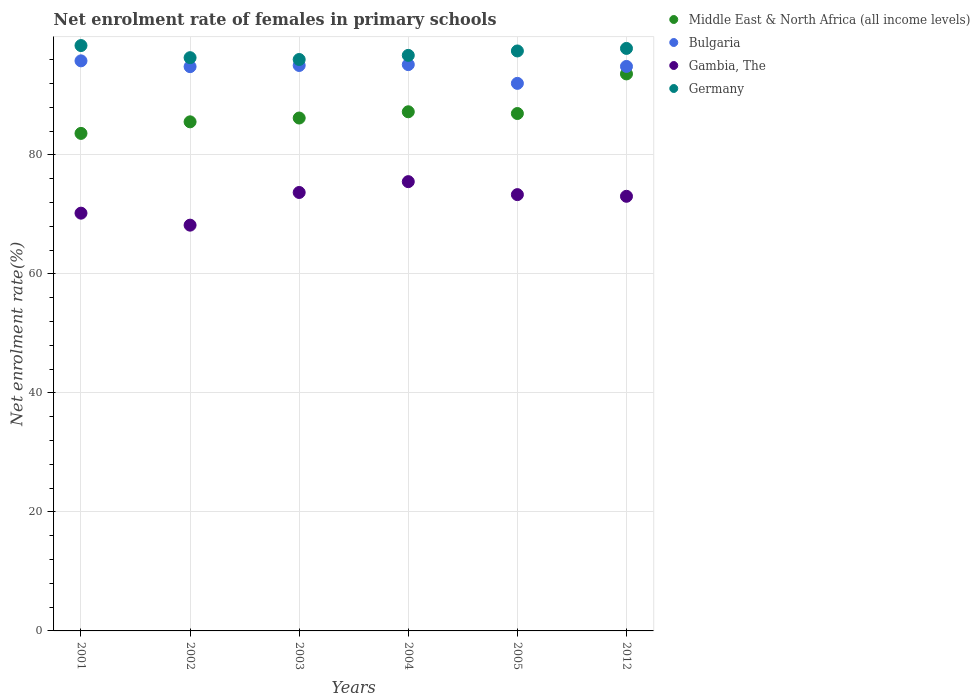Is the number of dotlines equal to the number of legend labels?
Offer a very short reply. Yes. What is the net enrolment rate of females in primary schools in Germany in 2002?
Provide a short and direct response. 96.33. Across all years, what is the maximum net enrolment rate of females in primary schools in Germany?
Make the answer very short. 98.37. Across all years, what is the minimum net enrolment rate of females in primary schools in Gambia, The?
Ensure brevity in your answer.  68.19. In which year was the net enrolment rate of females in primary schools in Middle East & North Africa (all income levels) maximum?
Keep it short and to the point. 2012. What is the total net enrolment rate of females in primary schools in Bulgaria in the graph?
Keep it short and to the point. 567.7. What is the difference between the net enrolment rate of females in primary schools in Bulgaria in 2003 and that in 2005?
Provide a short and direct response. 3.01. What is the difference between the net enrolment rate of females in primary schools in Middle East & North Africa (all income levels) in 2004 and the net enrolment rate of females in primary schools in Gambia, The in 2003?
Provide a short and direct response. 13.56. What is the average net enrolment rate of females in primary schools in Bulgaria per year?
Your answer should be very brief. 94.62. In the year 2003, what is the difference between the net enrolment rate of females in primary schools in Gambia, The and net enrolment rate of females in primary schools in Germany?
Your answer should be compact. -22.35. What is the ratio of the net enrolment rate of females in primary schools in Middle East & North Africa (all income levels) in 2002 to that in 2012?
Your answer should be very brief. 0.91. Is the net enrolment rate of females in primary schools in Gambia, The in 2002 less than that in 2003?
Your answer should be very brief. Yes. Is the difference between the net enrolment rate of females in primary schools in Gambia, The in 2001 and 2005 greater than the difference between the net enrolment rate of females in primary schools in Germany in 2001 and 2005?
Your answer should be very brief. No. What is the difference between the highest and the second highest net enrolment rate of females in primary schools in Germany?
Your answer should be very brief. 0.48. What is the difference between the highest and the lowest net enrolment rate of females in primary schools in Gambia, The?
Your answer should be compact. 7.31. In how many years, is the net enrolment rate of females in primary schools in Germany greater than the average net enrolment rate of females in primary schools in Germany taken over all years?
Your answer should be very brief. 3. Is the sum of the net enrolment rate of females in primary schools in Germany in 2001 and 2005 greater than the maximum net enrolment rate of females in primary schools in Gambia, The across all years?
Provide a short and direct response. Yes. Is it the case that in every year, the sum of the net enrolment rate of females in primary schools in Bulgaria and net enrolment rate of females in primary schools in Gambia, The  is greater than the net enrolment rate of females in primary schools in Germany?
Offer a very short reply. Yes. Is the net enrolment rate of females in primary schools in Middle East & North Africa (all income levels) strictly greater than the net enrolment rate of females in primary schools in Bulgaria over the years?
Make the answer very short. No. Are the values on the major ticks of Y-axis written in scientific E-notation?
Offer a terse response. No. Does the graph contain grids?
Give a very brief answer. Yes. How many legend labels are there?
Provide a short and direct response. 4. What is the title of the graph?
Provide a succinct answer. Net enrolment rate of females in primary schools. Does "Turks and Caicos Islands" appear as one of the legend labels in the graph?
Your answer should be compact. No. What is the label or title of the X-axis?
Make the answer very short. Years. What is the label or title of the Y-axis?
Make the answer very short. Net enrolment rate(%). What is the Net enrolment rate(%) in Middle East & North Africa (all income levels) in 2001?
Provide a succinct answer. 83.61. What is the Net enrolment rate(%) in Bulgaria in 2001?
Keep it short and to the point. 95.8. What is the Net enrolment rate(%) in Gambia, The in 2001?
Keep it short and to the point. 70.2. What is the Net enrolment rate(%) of Germany in 2001?
Keep it short and to the point. 98.37. What is the Net enrolment rate(%) in Middle East & North Africa (all income levels) in 2002?
Offer a very short reply. 85.55. What is the Net enrolment rate(%) of Bulgaria in 2002?
Make the answer very short. 94.83. What is the Net enrolment rate(%) of Gambia, The in 2002?
Your answer should be very brief. 68.19. What is the Net enrolment rate(%) in Germany in 2002?
Your response must be concise. 96.33. What is the Net enrolment rate(%) in Middle East & North Africa (all income levels) in 2003?
Your response must be concise. 86.19. What is the Net enrolment rate(%) in Bulgaria in 2003?
Keep it short and to the point. 95.02. What is the Net enrolment rate(%) in Gambia, The in 2003?
Provide a short and direct response. 73.68. What is the Net enrolment rate(%) of Germany in 2003?
Make the answer very short. 96.03. What is the Net enrolment rate(%) of Middle East & North Africa (all income levels) in 2004?
Make the answer very short. 87.24. What is the Net enrolment rate(%) of Bulgaria in 2004?
Your answer should be very brief. 95.17. What is the Net enrolment rate(%) of Gambia, The in 2004?
Your response must be concise. 75.5. What is the Net enrolment rate(%) of Germany in 2004?
Offer a very short reply. 96.72. What is the Net enrolment rate(%) of Middle East & North Africa (all income levels) in 2005?
Ensure brevity in your answer.  86.95. What is the Net enrolment rate(%) in Bulgaria in 2005?
Offer a very short reply. 92.02. What is the Net enrolment rate(%) in Gambia, The in 2005?
Your answer should be compact. 73.32. What is the Net enrolment rate(%) in Germany in 2005?
Provide a short and direct response. 97.46. What is the Net enrolment rate(%) of Middle East & North Africa (all income levels) in 2012?
Your answer should be compact. 93.61. What is the Net enrolment rate(%) in Bulgaria in 2012?
Provide a succinct answer. 94.86. What is the Net enrolment rate(%) of Gambia, The in 2012?
Your response must be concise. 73.04. What is the Net enrolment rate(%) in Germany in 2012?
Your response must be concise. 97.89. Across all years, what is the maximum Net enrolment rate(%) of Middle East & North Africa (all income levels)?
Make the answer very short. 93.61. Across all years, what is the maximum Net enrolment rate(%) of Bulgaria?
Your response must be concise. 95.8. Across all years, what is the maximum Net enrolment rate(%) of Gambia, The?
Make the answer very short. 75.5. Across all years, what is the maximum Net enrolment rate(%) of Germany?
Your response must be concise. 98.37. Across all years, what is the minimum Net enrolment rate(%) of Middle East & North Africa (all income levels)?
Offer a terse response. 83.61. Across all years, what is the minimum Net enrolment rate(%) in Bulgaria?
Provide a short and direct response. 92.02. Across all years, what is the minimum Net enrolment rate(%) of Gambia, The?
Your response must be concise. 68.19. Across all years, what is the minimum Net enrolment rate(%) in Germany?
Make the answer very short. 96.03. What is the total Net enrolment rate(%) in Middle East & North Africa (all income levels) in the graph?
Provide a succinct answer. 523.15. What is the total Net enrolment rate(%) in Bulgaria in the graph?
Your answer should be compact. 567.7. What is the total Net enrolment rate(%) of Gambia, The in the graph?
Ensure brevity in your answer.  433.94. What is the total Net enrolment rate(%) in Germany in the graph?
Keep it short and to the point. 582.81. What is the difference between the Net enrolment rate(%) of Middle East & North Africa (all income levels) in 2001 and that in 2002?
Offer a very short reply. -1.94. What is the difference between the Net enrolment rate(%) of Gambia, The in 2001 and that in 2002?
Ensure brevity in your answer.  2.02. What is the difference between the Net enrolment rate(%) of Germany in 2001 and that in 2002?
Make the answer very short. 2.04. What is the difference between the Net enrolment rate(%) of Middle East & North Africa (all income levels) in 2001 and that in 2003?
Provide a short and direct response. -2.58. What is the difference between the Net enrolment rate(%) in Bulgaria in 2001 and that in 2003?
Provide a short and direct response. 0.78. What is the difference between the Net enrolment rate(%) of Gambia, The in 2001 and that in 2003?
Provide a succinct answer. -3.48. What is the difference between the Net enrolment rate(%) of Germany in 2001 and that in 2003?
Provide a succinct answer. 2.34. What is the difference between the Net enrolment rate(%) of Middle East & North Africa (all income levels) in 2001 and that in 2004?
Make the answer very short. -3.63. What is the difference between the Net enrolment rate(%) of Bulgaria in 2001 and that in 2004?
Provide a succinct answer. 0.63. What is the difference between the Net enrolment rate(%) of Gambia, The in 2001 and that in 2004?
Your response must be concise. -5.3. What is the difference between the Net enrolment rate(%) in Germany in 2001 and that in 2004?
Make the answer very short. 1.65. What is the difference between the Net enrolment rate(%) in Middle East & North Africa (all income levels) in 2001 and that in 2005?
Your response must be concise. -3.34. What is the difference between the Net enrolment rate(%) in Bulgaria in 2001 and that in 2005?
Offer a terse response. 3.78. What is the difference between the Net enrolment rate(%) in Gambia, The in 2001 and that in 2005?
Give a very brief answer. -3.12. What is the difference between the Net enrolment rate(%) of Germany in 2001 and that in 2005?
Offer a very short reply. 0.91. What is the difference between the Net enrolment rate(%) in Middle East & North Africa (all income levels) in 2001 and that in 2012?
Ensure brevity in your answer.  -10. What is the difference between the Net enrolment rate(%) in Bulgaria in 2001 and that in 2012?
Give a very brief answer. 0.94. What is the difference between the Net enrolment rate(%) in Gambia, The in 2001 and that in 2012?
Offer a terse response. -2.83. What is the difference between the Net enrolment rate(%) in Germany in 2001 and that in 2012?
Provide a short and direct response. 0.48. What is the difference between the Net enrolment rate(%) in Middle East & North Africa (all income levels) in 2002 and that in 2003?
Offer a very short reply. -0.64. What is the difference between the Net enrolment rate(%) of Bulgaria in 2002 and that in 2003?
Offer a very short reply. -0.2. What is the difference between the Net enrolment rate(%) of Gambia, The in 2002 and that in 2003?
Your answer should be compact. -5.49. What is the difference between the Net enrolment rate(%) of Germany in 2002 and that in 2003?
Keep it short and to the point. 0.31. What is the difference between the Net enrolment rate(%) in Middle East & North Africa (all income levels) in 2002 and that in 2004?
Give a very brief answer. -1.69. What is the difference between the Net enrolment rate(%) in Bulgaria in 2002 and that in 2004?
Provide a short and direct response. -0.34. What is the difference between the Net enrolment rate(%) of Gambia, The in 2002 and that in 2004?
Your answer should be very brief. -7.31. What is the difference between the Net enrolment rate(%) in Germany in 2002 and that in 2004?
Offer a terse response. -0.39. What is the difference between the Net enrolment rate(%) of Middle East & North Africa (all income levels) in 2002 and that in 2005?
Your response must be concise. -1.4. What is the difference between the Net enrolment rate(%) in Bulgaria in 2002 and that in 2005?
Provide a succinct answer. 2.81. What is the difference between the Net enrolment rate(%) in Gambia, The in 2002 and that in 2005?
Your answer should be compact. -5.13. What is the difference between the Net enrolment rate(%) of Germany in 2002 and that in 2005?
Your response must be concise. -1.13. What is the difference between the Net enrolment rate(%) in Middle East & North Africa (all income levels) in 2002 and that in 2012?
Your answer should be compact. -8.05. What is the difference between the Net enrolment rate(%) in Bulgaria in 2002 and that in 2012?
Offer a terse response. -0.04. What is the difference between the Net enrolment rate(%) in Gambia, The in 2002 and that in 2012?
Give a very brief answer. -4.85. What is the difference between the Net enrolment rate(%) of Germany in 2002 and that in 2012?
Offer a terse response. -1.56. What is the difference between the Net enrolment rate(%) of Middle East & North Africa (all income levels) in 2003 and that in 2004?
Your answer should be compact. -1.05. What is the difference between the Net enrolment rate(%) in Bulgaria in 2003 and that in 2004?
Offer a terse response. -0.14. What is the difference between the Net enrolment rate(%) in Gambia, The in 2003 and that in 2004?
Your response must be concise. -1.82. What is the difference between the Net enrolment rate(%) in Germany in 2003 and that in 2004?
Make the answer very short. -0.69. What is the difference between the Net enrolment rate(%) in Middle East & North Africa (all income levels) in 2003 and that in 2005?
Provide a short and direct response. -0.76. What is the difference between the Net enrolment rate(%) of Bulgaria in 2003 and that in 2005?
Provide a succinct answer. 3.01. What is the difference between the Net enrolment rate(%) of Gambia, The in 2003 and that in 2005?
Offer a very short reply. 0.36. What is the difference between the Net enrolment rate(%) of Germany in 2003 and that in 2005?
Your answer should be very brief. -1.43. What is the difference between the Net enrolment rate(%) in Middle East & North Africa (all income levels) in 2003 and that in 2012?
Provide a short and direct response. -7.41. What is the difference between the Net enrolment rate(%) in Bulgaria in 2003 and that in 2012?
Ensure brevity in your answer.  0.16. What is the difference between the Net enrolment rate(%) in Gambia, The in 2003 and that in 2012?
Ensure brevity in your answer.  0.64. What is the difference between the Net enrolment rate(%) of Germany in 2003 and that in 2012?
Your answer should be very brief. -1.86. What is the difference between the Net enrolment rate(%) in Middle East & North Africa (all income levels) in 2004 and that in 2005?
Give a very brief answer. 0.29. What is the difference between the Net enrolment rate(%) in Bulgaria in 2004 and that in 2005?
Offer a terse response. 3.15. What is the difference between the Net enrolment rate(%) of Gambia, The in 2004 and that in 2005?
Offer a very short reply. 2.18. What is the difference between the Net enrolment rate(%) of Germany in 2004 and that in 2005?
Offer a very short reply. -0.74. What is the difference between the Net enrolment rate(%) of Middle East & North Africa (all income levels) in 2004 and that in 2012?
Give a very brief answer. -6.36. What is the difference between the Net enrolment rate(%) in Bulgaria in 2004 and that in 2012?
Give a very brief answer. 0.31. What is the difference between the Net enrolment rate(%) in Gambia, The in 2004 and that in 2012?
Your answer should be very brief. 2.46. What is the difference between the Net enrolment rate(%) in Germany in 2004 and that in 2012?
Provide a short and direct response. -1.17. What is the difference between the Net enrolment rate(%) of Middle East & North Africa (all income levels) in 2005 and that in 2012?
Ensure brevity in your answer.  -6.65. What is the difference between the Net enrolment rate(%) of Bulgaria in 2005 and that in 2012?
Ensure brevity in your answer.  -2.85. What is the difference between the Net enrolment rate(%) in Gambia, The in 2005 and that in 2012?
Make the answer very short. 0.28. What is the difference between the Net enrolment rate(%) of Germany in 2005 and that in 2012?
Keep it short and to the point. -0.43. What is the difference between the Net enrolment rate(%) of Middle East & North Africa (all income levels) in 2001 and the Net enrolment rate(%) of Bulgaria in 2002?
Give a very brief answer. -11.22. What is the difference between the Net enrolment rate(%) in Middle East & North Africa (all income levels) in 2001 and the Net enrolment rate(%) in Gambia, The in 2002?
Your answer should be compact. 15.42. What is the difference between the Net enrolment rate(%) of Middle East & North Africa (all income levels) in 2001 and the Net enrolment rate(%) of Germany in 2002?
Your answer should be very brief. -12.72. What is the difference between the Net enrolment rate(%) in Bulgaria in 2001 and the Net enrolment rate(%) in Gambia, The in 2002?
Ensure brevity in your answer.  27.61. What is the difference between the Net enrolment rate(%) of Bulgaria in 2001 and the Net enrolment rate(%) of Germany in 2002?
Your answer should be very brief. -0.53. What is the difference between the Net enrolment rate(%) in Gambia, The in 2001 and the Net enrolment rate(%) in Germany in 2002?
Your response must be concise. -26.13. What is the difference between the Net enrolment rate(%) of Middle East & North Africa (all income levels) in 2001 and the Net enrolment rate(%) of Bulgaria in 2003?
Offer a terse response. -11.41. What is the difference between the Net enrolment rate(%) of Middle East & North Africa (all income levels) in 2001 and the Net enrolment rate(%) of Gambia, The in 2003?
Keep it short and to the point. 9.93. What is the difference between the Net enrolment rate(%) of Middle East & North Africa (all income levels) in 2001 and the Net enrolment rate(%) of Germany in 2003?
Your answer should be compact. -12.42. What is the difference between the Net enrolment rate(%) in Bulgaria in 2001 and the Net enrolment rate(%) in Gambia, The in 2003?
Your answer should be compact. 22.12. What is the difference between the Net enrolment rate(%) in Bulgaria in 2001 and the Net enrolment rate(%) in Germany in 2003?
Offer a terse response. -0.23. What is the difference between the Net enrolment rate(%) in Gambia, The in 2001 and the Net enrolment rate(%) in Germany in 2003?
Provide a succinct answer. -25.82. What is the difference between the Net enrolment rate(%) of Middle East & North Africa (all income levels) in 2001 and the Net enrolment rate(%) of Bulgaria in 2004?
Offer a terse response. -11.56. What is the difference between the Net enrolment rate(%) of Middle East & North Africa (all income levels) in 2001 and the Net enrolment rate(%) of Gambia, The in 2004?
Your answer should be compact. 8.11. What is the difference between the Net enrolment rate(%) in Middle East & North Africa (all income levels) in 2001 and the Net enrolment rate(%) in Germany in 2004?
Offer a terse response. -13.11. What is the difference between the Net enrolment rate(%) in Bulgaria in 2001 and the Net enrolment rate(%) in Gambia, The in 2004?
Give a very brief answer. 20.3. What is the difference between the Net enrolment rate(%) in Bulgaria in 2001 and the Net enrolment rate(%) in Germany in 2004?
Offer a terse response. -0.92. What is the difference between the Net enrolment rate(%) in Gambia, The in 2001 and the Net enrolment rate(%) in Germany in 2004?
Your answer should be very brief. -26.52. What is the difference between the Net enrolment rate(%) of Middle East & North Africa (all income levels) in 2001 and the Net enrolment rate(%) of Bulgaria in 2005?
Your response must be concise. -8.41. What is the difference between the Net enrolment rate(%) of Middle East & North Africa (all income levels) in 2001 and the Net enrolment rate(%) of Gambia, The in 2005?
Your response must be concise. 10.29. What is the difference between the Net enrolment rate(%) of Middle East & North Africa (all income levels) in 2001 and the Net enrolment rate(%) of Germany in 2005?
Ensure brevity in your answer.  -13.85. What is the difference between the Net enrolment rate(%) in Bulgaria in 2001 and the Net enrolment rate(%) in Gambia, The in 2005?
Your response must be concise. 22.48. What is the difference between the Net enrolment rate(%) in Bulgaria in 2001 and the Net enrolment rate(%) in Germany in 2005?
Your answer should be compact. -1.66. What is the difference between the Net enrolment rate(%) of Gambia, The in 2001 and the Net enrolment rate(%) of Germany in 2005?
Offer a terse response. -27.26. What is the difference between the Net enrolment rate(%) in Middle East & North Africa (all income levels) in 2001 and the Net enrolment rate(%) in Bulgaria in 2012?
Offer a very short reply. -11.25. What is the difference between the Net enrolment rate(%) of Middle East & North Africa (all income levels) in 2001 and the Net enrolment rate(%) of Gambia, The in 2012?
Your response must be concise. 10.57. What is the difference between the Net enrolment rate(%) in Middle East & North Africa (all income levels) in 2001 and the Net enrolment rate(%) in Germany in 2012?
Ensure brevity in your answer.  -14.28. What is the difference between the Net enrolment rate(%) in Bulgaria in 2001 and the Net enrolment rate(%) in Gambia, The in 2012?
Make the answer very short. 22.76. What is the difference between the Net enrolment rate(%) of Bulgaria in 2001 and the Net enrolment rate(%) of Germany in 2012?
Provide a succinct answer. -2.09. What is the difference between the Net enrolment rate(%) in Gambia, The in 2001 and the Net enrolment rate(%) in Germany in 2012?
Your response must be concise. -27.69. What is the difference between the Net enrolment rate(%) of Middle East & North Africa (all income levels) in 2002 and the Net enrolment rate(%) of Bulgaria in 2003?
Offer a very short reply. -9.47. What is the difference between the Net enrolment rate(%) in Middle East & North Africa (all income levels) in 2002 and the Net enrolment rate(%) in Gambia, The in 2003?
Your response must be concise. 11.87. What is the difference between the Net enrolment rate(%) of Middle East & North Africa (all income levels) in 2002 and the Net enrolment rate(%) of Germany in 2003?
Ensure brevity in your answer.  -10.48. What is the difference between the Net enrolment rate(%) in Bulgaria in 2002 and the Net enrolment rate(%) in Gambia, The in 2003?
Offer a terse response. 21.15. What is the difference between the Net enrolment rate(%) in Bulgaria in 2002 and the Net enrolment rate(%) in Germany in 2003?
Provide a succinct answer. -1.2. What is the difference between the Net enrolment rate(%) of Gambia, The in 2002 and the Net enrolment rate(%) of Germany in 2003?
Provide a succinct answer. -27.84. What is the difference between the Net enrolment rate(%) of Middle East & North Africa (all income levels) in 2002 and the Net enrolment rate(%) of Bulgaria in 2004?
Keep it short and to the point. -9.62. What is the difference between the Net enrolment rate(%) of Middle East & North Africa (all income levels) in 2002 and the Net enrolment rate(%) of Gambia, The in 2004?
Your response must be concise. 10.05. What is the difference between the Net enrolment rate(%) of Middle East & North Africa (all income levels) in 2002 and the Net enrolment rate(%) of Germany in 2004?
Offer a terse response. -11.17. What is the difference between the Net enrolment rate(%) of Bulgaria in 2002 and the Net enrolment rate(%) of Gambia, The in 2004?
Offer a terse response. 19.32. What is the difference between the Net enrolment rate(%) in Bulgaria in 2002 and the Net enrolment rate(%) in Germany in 2004?
Keep it short and to the point. -1.9. What is the difference between the Net enrolment rate(%) of Gambia, The in 2002 and the Net enrolment rate(%) of Germany in 2004?
Ensure brevity in your answer.  -28.53. What is the difference between the Net enrolment rate(%) of Middle East & North Africa (all income levels) in 2002 and the Net enrolment rate(%) of Bulgaria in 2005?
Provide a succinct answer. -6.46. What is the difference between the Net enrolment rate(%) of Middle East & North Africa (all income levels) in 2002 and the Net enrolment rate(%) of Gambia, The in 2005?
Your answer should be very brief. 12.23. What is the difference between the Net enrolment rate(%) of Middle East & North Africa (all income levels) in 2002 and the Net enrolment rate(%) of Germany in 2005?
Make the answer very short. -11.91. What is the difference between the Net enrolment rate(%) in Bulgaria in 2002 and the Net enrolment rate(%) in Gambia, The in 2005?
Provide a succinct answer. 21.51. What is the difference between the Net enrolment rate(%) in Bulgaria in 2002 and the Net enrolment rate(%) in Germany in 2005?
Keep it short and to the point. -2.64. What is the difference between the Net enrolment rate(%) of Gambia, The in 2002 and the Net enrolment rate(%) of Germany in 2005?
Offer a very short reply. -29.27. What is the difference between the Net enrolment rate(%) of Middle East & North Africa (all income levels) in 2002 and the Net enrolment rate(%) of Bulgaria in 2012?
Offer a terse response. -9.31. What is the difference between the Net enrolment rate(%) in Middle East & North Africa (all income levels) in 2002 and the Net enrolment rate(%) in Gambia, The in 2012?
Make the answer very short. 12.51. What is the difference between the Net enrolment rate(%) in Middle East & North Africa (all income levels) in 2002 and the Net enrolment rate(%) in Germany in 2012?
Keep it short and to the point. -12.34. What is the difference between the Net enrolment rate(%) in Bulgaria in 2002 and the Net enrolment rate(%) in Gambia, The in 2012?
Your answer should be compact. 21.79. What is the difference between the Net enrolment rate(%) in Bulgaria in 2002 and the Net enrolment rate(%) in Germany in 2012?
Keep it short and to the point. -3.06. What is the difference between the Net enrolment rate(%) of Gambia, The in 2002 and the Net enrolment rate(%) of Germany in 2012?
Give a very brief answer. -29.7. What is the difference between the Net enrolment rate(%) of Middle East & North Africa (all income levels) in 2003 and the Net enrolment rate(%) of Bulgaria in 2004?
Offer a very short reply. -8.98. What is the difference between the Net enrolment rate(%) in Middle East & North Africa (all income levels) in 2003 and the Net enrolment rate(%) in Gambia, The in 2004?
Provide a short and direct response. 10.69. What is the difference between the Net enrolment rate(%) in Middle East & North Africa (all income levels) in 2003 and the Net enrolment rate(%) in Germany in 2004?
Keep it short and to the point. -10.53. What is the difference between the Net enrolment rate(%) of Bulgaria in 2003 and the Net enrolment rate(%) of Gambia, The in 2004?
Your answer should be very brief. 19.52. What is the difference between the Net enrolment rate(%) of Bulgaria in 2003 and the Net enrolment rate(%) of Germany in 2004?
Give a very brief answer. -1.7. What is the difference between the Net enrolment rate(%) of Gambia, The in 2003 and the Net enrolment rate(%) of Germany in 2004?
Your response must be concise. -23.04. What is the difference between the Net enrolment rate(%) in Middle East & North Africa (all income levels) in 2003 and the Net enrolment rate(%) in Bulgaria in 2005?
Offer a terse response. -5.82. What is the difference between the Net enrolment rate(%) in Middle East & North Africa (all income levels) in 2003 and the Net enrolment rate(%) in Gambia, The in 2005?
Ensure brevity in your answer.  12.87. What is the difference between the Net enrolment rate(%) in Middle East & North Africa (all income levels) in 2003 and the Net enrolment rate(%) in Germany in 2005?
Provide a short and direct response. -11.27. What is the difference between the Net enrolment rate(%) in Bulgaria in 2003 and the Net enrolment rate(%) in Gambia, The in 2005?
Offer a very short reply. 21.7. What is the difference between the Net enrolment rate(%) in Bulgaria in 2003 and the Net enrolment rate(%) in Germany in 2005?
Offer a very short reply. -2.44. What is the difference between the Net enrolment rate(%) of Gambia, The in 2003 and the Net enrolment rate(%) of Germany in 2005?
Your answer should be very brief. -23.78. What is the difference between the Net enrolment rate(%) of Middle East & North Africa (all income levels) in 2003 and the Net enrolment rate(%) of Bulgaria in 2012?
Provide a succinct answer. -8.67. What is the difference between the Net enrolment rate(%) in Middle East & North Africa (all income levels) in 2003 and the Net enrolment rate(%) in Gambia, The in 2012?
Provide a short and direct response. 13.15. What is the difference between the Net enrolment rate(%) of Middle East & North Africa (all income levels) in 2003 and the Net enrolment rate(%) of Germany in 2012?
Provide a succinct answer. -11.7. What is the difference between the Net enrolment rate(%) of Bulgaria in 2003 and the Net enrolment rate(%) of Gambia, The in 2012?
Your answer should be compact. 21.98. What is the difference between the Net enrolment rate(%) in Bulgaria in 2003 and the Net enrolment rate(%) in Germany in 2012?
Your response must be concise. -2.87. What is the difference between the Net enrolment rate(%) in Gambia, The in 2003 and the Net enrolment rate(%) in Germany in 2012?
Make the answer very short. -24.21. What is the difference between the Net enrolment rate(%) in Middle East & North Africa (all income levels) in 2004 and the Net enrolment rate(%) in Bulgaria in 2005?
Ensure brevity in your answer.  -4.77. What is the difference between the Net enrolment rate(%) of Middle East & North Africa (all income levels) in 2004 and the Net enrolment rate(%) of Gambia, The in 2005?
Keep it short and to the point. 13.92. What is the difference between the Net enrolment rate(%) in Middle East & North Africa (all income levels) in 2004 and the Net enrolment rate(%) in Germany in 2005?
Your response must be concise. -10.22. What is the difference between the Net enrolment rate(%) in Bulgaria in 2004 and the Net enrolment rate(%) in Gambia, The in 2005?
Give a very brief answer. 21.85. What is the difference between the Net enrolment rate(%) of Bulgaria in 2004 and the Net enrolment rate(%) of Germany in 2005?
Provide a short and direct response. -2.29. What is the difference between the Net enrolment rate(%) of Gambia, The in 2004 and the Net enrolment rate(%) of Germany in 2005?
Give a very brief answer. -21.96. What is the difference between the Net enrolment rate(%) in Middle East & North Africa (all income levels) in 2004 and the Net enrolment rate(%) in Bulgaria in 2012?
Provide a short and direct response. -7.62. What is the difference between the Net enrolment rate(%) of Middle East & North Africa (all income levels) in 2004 and the Net enrolment rate(%) of Gambia, The in 2012?
Your answer should be compact. 14.2. What is the difference between the Net enrolment rate(%) of Middle East & North Africa (all income levels) in 2004 and the Net enrolment rate(%) of Germany in 2012?
Provide a succinct answer. -10.65. What is the difference between the Net enrolment rate(%) in Bulgaria in 2004 and the Net enrolment rate(%) in Gambia, The in 2012?
Ensure brevity in your answer.  22.13. What is the difference between the Net enrolment rate(%) in Bulgaria in 2004 and the Net enrolment rate(%) in Germany in 2012?
Provide a short and direct response. -2.72. What is the difference between the Net enrolment rate(%) in Gambia, The in 2004 and the Net enrolment rate(%) in Germany in 2012?
Provide a succinct answer. -22.39. What is the difference between the Net enrolment rate(%) in Middle East & North Africa (all income levels) in 2005 and the Net enrolment rate(%) in Bulgaria in 2012?
Give a very brief answer. -7.91. What is the difference between the Net enrolment rate(%) in Middle East & North Africa (all income levels) in 2005 and the Net enrolment rate(%) in Gambia, The in 2012?
Give a very brief answer. 13.91. What is the difference between the Net enrolment rate(%) in Middle East & North Africa (all income levels) in 2005 and the Net enrolment rate(%) in Germany in 2012?
Your response must be concise. -10.94. What is the difference between the Net enrolment rate(%) of Bulgaria in 2005 and the Net enrolment rate(%) of Gambia, The in 2012?
Provide a succinct answer. 18.98. What is the difference between the Net enrolment rate(%) of Bulgaria in 2005 and the Net enrolment rate(%) of Germany in 2012?
Offer a terse response. -5.87. What is the difference between the Net enrolment rate(%) of Gambia, The in 2005 and the Net enrolment rate(%) of Germany in 2012?
Your answer should be very brief. -24.57. What is the average Net enrolment rate(%) in Middle East & North Africa (all income levels) per year?
Your answer should be very brief. 87.19. What is the average Net enrolment rate(%) in Bulgaria per year?
Make the answer very short. 94.62. What is the average Net enrolment rate(%) of Gambia, The per year?
Make the answer very short. 72.32. What is the average Net enrolment rate(%) of Germany per year?
Provide a short and direct response. 97.14. In the year 2001, what is the difference between the Net enrolment rate(%) of Middle East & North Africa (all income levels) and Net enrolment rate(%) of Bulgaria?
Your answer should be compact. -12.19. In the year 2001, what is the difference between the Net enrolment rate(%) of Middle East & North Africa (all income levels) and Net enrolment rate(%) of Gambia, The?
Give a very brief answer. 13.4. In the year 2001, what is the difference between the Net enrolment rate(%) in Middle East & North Africa (all income levels) and Net enrolment rate(%) in Germany?
Ensure brevity in your answer.  -14.76. In the year 2001, what is the difference between the Net enrolment rate(%) of Bulgaria and Net enrolment rate(%) of Gambia, The?
Make the answer very short. 25.6. In the year 2001, what is the difference between the Net enrolment rate(%) of Bulgaria and Net enrolment rate(%) of Germany?
Your answer should be compact. -2.57. In the year 2001, what is the difference between the Net enrolment rate(%) in Gambia, The and Net enrolment rate(%) in Germany?
Your answer should be very brief. -28.17. In the year 2002, what is the difference between the Net enrolment rate(%) in Middle East & North Africa (all income levels) and Net enrolment rate(%) in Bulgaria?
Provide a short and direct response. -9.27. In the year 2002, what is the difference between the Net enrolment rate(%) of Middle East & North Africa (all income levels) and Net enrolment rate(%) of Gambia, The?
Offer a terse response. 17.36. In the year 2002, what is the difference between the Net enrolment rate(%) in Middle East & North Africa (all income levels) and Net enrolment rate(%) in Germany?
Keep it short and to the point. -10.78. In the year 2002, what is the difference between the Net enrolment rate(%) of Bulgaria and Net enrolment rate(%) of Gambia, The?
Offer a very short reply. 26.64. In the year 2002, what is the difference between the Net enrolment rate(%) of Bulgaria and Net enrolment rate(%) of Germany?
Provide a succinct answer. -1.51. In the year 2002, what is the difference between the Net enrolment rate(%) of Gambia, The and Net enrolment rate(%) of Germany?
Ensure brevity in your answer.  -28.15. In the year 2003, what is the difference between the Net enrolment rate(%) of Middle East & North Africa (all income levels) and Net enrolment rate(%) of Bulgaria?
Your response must be concise. -8.83. In the year 2003, what is the difference between the Net enrolment rate(%) of Middle East & North Africa (all income levels) and Net enrolment rate(%) of Gambia, The?
Ensure brevity in your answer.  12.51. In the year 2003, what is the difference between the Net enrolment rate(%) in Middle East & North Africa (all income levels) and Net enrolment rate(%) in Germany?
Ensure brevity in your answer.  -9.84. In the year 2003, what is the difference between the Net enrolment rate(%) of Bulgaria and Net enrolment rate(%) of Gambia, The?
Provide a succinct answer. 21.34. In the year 2003, what is the difference between the Net enrolment rate(%) of Bulgaria and Net enrolment rate(%) of Germany?
Your response must be concise. -1. In the year 2003, what is the difference between the Net enrolment rate(%) in Gambia, The and Net enrolment rate(%) in Germany?
Offer a very short reply. -22.35. In the year 2004, what is the difference between the Net enrolment rate(%) in Middle East & North Africa (all income levels) and Net enrolment rate(%) in Bulgaria?
Ensure brevity in your answer.  -7.93. In the year 2004, what is the difference between the Net enrolment rate(%) in Middle East & North Africa (all income levels) and Net enrolment rate(%) in Gambia, The?
Provide a succinct answer. 11.74. In the year 2004, what is the difference between the Net enrolment rate(%) in Middle East & North Africa (all income levels) and Net enrolment rate(%) in Germany?
Provide a succinct answer. -9.48. In the year 2004, what is the difference between the Net enrolment rate(%) of Bulgaria and Net enrolment rate(%) of Gambia, The?
Keep it short and to the point. 19.67. In the year 2004, what is the difference between the Net enrolment rate(%) in Bulgaria and Net enrolment rate(%) in Germany?
Offer a terse response. -1.55. In the year 2004, what is the difference between the Net enrolment rate(%) in Gambia, The and Net enrolment rate(%) in Germany?
Offer a terse response. -21.22. In the year 2005, what is the difference between the Net enrolment rate(%) of Middle East & North Africa (all income levels) and Net enrolment rate(%) of Bulgaria?
Your answer should be compact. -5.07. In the year 2005, what is the difference between the Net enrolment rate(%) of Middle East & North Africa (all income levels) and Net enrolment rate(%) of Gambia, The?
Offer a very short reply. 13.63. In the year 2005, what is the difference between the Net enrolment rate(%) in Middle East & North Africa (all income levels) and Net enrolment rate(%) in Germany?
Provide a short and direct response. -10.51. In the year 2005, what is the difference between the Net enrolment rate(%) of Bulgaria and Net enrolment rate(%) of Gambia, The?
Give a very brief answer. 18.7. In the year 2005, what is the difference between the Net enrolment rate(%) of Bulgaria and Net enrolment rate(%) of Germany?
Keep it short and to the point. -5.45. In the year 2005, what is the difference between the Net enrolment rate(%) in Gambia, The and Net enrolment rate(%) in Germany?
Keep it short and to the point. -24.14. In the year 2012, what is the difference between the Net enrolment rate(%) in Middle East & North Africa (all income levels) and Net enrolment rate(%) in Bulgaria?
Keep it short and to the point. -1.26. In the year 2012, what is the difference between the Net enrolment rate(%) in Middle East & North Africa (all income levels) and Net enrolment rate(%) in Gambia, The?
Provide a short and direct response. 20.57. In the year 2012, what is the difference between the Net enrolment rate(%) in Middle East & North Africa (all income levels) and Net enrolment rate(%) in Germany?
Your answer should be compact. -4.29. In the year 2012, what is the difference between the Net enrolment rate(%) in Bulgaria and Net enrolment rate(%) in Gambia, The?
Keep it short and to the point. 21.82. In the year 2012, what is the difference between the Net enrolment rate(%) of Bulgaria and Net enrolment rate(%) of Germany?
Make the answer very short. -3.03. In the year 2012, what is the difference between the Net enrolment rate(%) in Gambia, The and Net enrolment rate(%) in Germany?
Provide a short and direct response. -24.85. What is the ratio of the Net enrolment rate(%) of Middle East & North Africa (all income levels) in 2001 to that in 2002?
Provide a succinct answer. 0.98. What is the ratio of the Net enrolment rate(%) in Bulgaria in 2001 to that in 2002?
Make the answer very short. 1.01. What is the ratio of the Net enrolment rate(%) of Gambia, The in 2001 to that in 2002?
Provide a succinct answer. 1.03. What is the ratio of the Net enrolment rate(%) in Germany in 2001 to that in 2002?
Your answer should be compact. 1.02. What is the ratio of the Net enrolment rate(%) of Middle East & North Africa (all income levels) in 2001 to that in 2003?
Give a very brief answer. 0.97. What is the ratio of the Net enrolment rate(%) in Bulgaria in 2001 to that in 2003?
Provide a succinct answer. 1.01. What is the ratio of the Net enrolment rate(%) in Gambia, The in 2001 to that in 2003?
Your answer should be compact. 0.95. What is the ratio of the Net enrolment rate(%) in Germany in 2001 to that in 2003?
Your answer should be compact. 1.02. What is the ratio of the Net enrolment rate(%) in Middle East & North Africa (all income levels) in 2001 to that in 2004?
Provide a short and direct response. 0.96. What is the ratio of the Net enrolment rate(%) of Bulgaria in 2001 to that in 2004?
Keep it short and to the point. 1.01. What is the ratio of the Net enrolment rate(%) in Gambia, The in 2001 to that in 2004?
Provide a short and direct response. 0.93. What is the ratio of the Net enrolment rate(%) in Germany in 2001 to that in 2004?
Provide a short and direct response. 1.02. What is the ratio of the Net enrolment rate(%) of Middle East & North Africa (all income levels) in 2001 to that in 2005?
Your answer should be very brief. 0.96. What is the ratio of the Net enrolment rate(%) of Bulgaria in 2001 to that in 2005?
Provide a short and direct response. 1.04. What is the ratio of the Net enrolment rate(%) of Gambia, The in 2001 to that in 2005?
Provide a short and direct response. 0.96. What is the ratio of the Net enrolment rate(%) of Germany in 2001 to that in 2005?
Your answer should be very brief. 1.01. What is the ratio of the Net enrolment rate(%) in Middle East & North Africa (all income levels) in 2001 to that in 2012?
Offer a very short reply. 0.89. What is the ratio of the Net enrolment rate(%) of Bulgaria in 2001 to that in 2012?
Ensure brevity in your answer.  1.01. What is the ratio of the Net enrolment rate(%) of Gambia, The in 2001 to that in 2012?
Offer a very short reply. 0.96. What is the ratio of the Net enrolment rate(%) of Germany in 2001 to that in 2012?
Your answer should be very brief. 1. What is the ratio of the Net enrolment rate(%) of Bulgaria in 2002 to that in 2003?
Your response must be concise. 1. What is the ratio of the Net enrolment rate(%) of Gambia, The in 2002 to that in 2003?
Provide a succinct answer. 0.93. What is the ratio of the Net enrolment rate(%) of Middle East & North Africa (all income levels) in 2002 to that in 2004?
Provide a succinct answer. 0.98. What is the ratio of the Net enrolment rate(%) in Gambia, The in 2002 to that in 2004?
Offer a terse response. 0.9. What is the ratio of the Net enrolment rate(%) of Middle East & North Africa (all income levels) in 2002 to that in 2005?
Offer a very short reply. 0.98. What is the ratio of the Net enrolment rate(%) in Bulgaria in 2002 to that in 2005?
Offer a terse response. 1.03. What is the ratio of the Net enrolment rate(%) in Germany in 2002 to that in 2005?
Offer a very short reply. 0.99. What is the ratio of the Net enrolment rate(%) of Middle East & North Africa (all income levels) in 2002 to that in 2012?
Ensure brevity in your answer.  0.91. What is the ratio of the Net enrolment rate(%) of Bulgaria in 2002 to that in 2012?
Offer a very short reply. 1. What is the ratio of the Net enrolment rate(%) of Gambia, The in 2002 to that in 2012?
Ensure brevity in your answer.  0.93. What is the ratio of the Net enrolment rate(%) of Germany in 2002 to that in 2012?
Offer a terse response. 0.98. What is the ratio of the Net enrolment rate(%) in Middle East & North Africa (all income levels) in 2003 to that in 2004?
Your answer should be very brief. 0.99. What is the ratio of the Net enrolment rate(%) of Bulgaria in 2003 to that in 2004?
Your answer should be compact. 1. What is the ratio of the Net enrolment rate(%) of Gambia, The in 2003 to that in 2004?
Offer a very short reply. 0.98. What is the ratio of the Net enrolment rate(%) in Middle East & North Africa (all income levels) in 2003 to that in 2005?
Provide a short and direct response. 0.99. What is the ratio of the Net enrolment rate(%) in Bulgaria in 2003 to that in 2005?
Keep it short and to the point. 1.03. What is the ratio of the Net enrolment rate(%) in Gambia, The in 2003 to that in 2005?
Make the answer very short. 1. What is the ratio of the Net enrolment rate(%) in Middle East & North Africa (all income levels) in 2003 to that in 2012?
Your response must be concise. 0.92. What is the ratio of the Net enrolment rate(%) in Gambia, The in 2003 to that in 2012?
Offer a very short reply. 1.01. What is the ratio of the Net enrolment rate(%) of Germany in 2003 to that in 2012?
Give a very brief answer. 0.98. What is the ratio of the Net enrolment rate(%) of Middle East & North Africa (all income levels) in 2004 to that in 2005?
Give a very brief answer. 1. What is the ratio of the Net enrolment rate(%) in Bulgaria in 2004 to that in 2005?
Ensure brevity in your answer.  1.03. What is the ratio of the Net enrolment rate(%) in Gambia, The in 2004 to that in 2005?
Make the answer very short. 1.03. What is the ratio of the Net enrolment rate(%) of Germany in 2004 to that in 2005?
Your answer should be compact. 0.99. What is the ratio of the Net enrolment rate(%) in Middle East & North Africa (all income levels) in 2004 to that in 2012?
Your response must be concise. 0.93. What is the ratio of the Net enrolment rate(%) of Gambia, The in 2004 to that in 2012?
Offer a terse response. 1.03. What is the ratio of the Net enrolment rate(%) in Middle East & North Africa (all income levels) in 2005 to that in 2012?
Offer a very short reply. 0.93. What is the ratio of the Net enrolment rate(%) in Gambia, The in 2005 to that in 2012?
Your answer should be compact. 1. What is the ratio of the Net enrolment rate(%) in Germany in 2005 to that in 2012?
Provide a succinct answer. 1. What is the difference between the highest and the second highest Net enrolment rate(%) of Middle East & North Africa (all income levels)?
Keep it short and to the point. 6.36. What is the difference between the highest and the second highest Net enrolment rate(%) in Bulgaria?
Your answer should be compact. 0.63. What is the difference between the highest and the second highest Net enrolment rate(%) in Gambia, The?
Keep it short and to the point. 1.82. What is the difference between the highest and the second highest Net enrolment rate(%) in Germany?
Provide a short and direct response. 0.48. What is the difference between the highest and the lowest Net enrolment rate(%) of Middle East & North Africa (all income levels)?
Your answer should be very brief. 10. What is the difference between the highest and the lowest Net enrolment rate(%) in Bulgaria?
Make the answer very short. 3.78. What is the difference between the highest and the lowest Net enrolment rate(%) in Gambia, The?
Provide a short and direct response. 7.31. What is the difference between the highest and the lowest Net enrolment rate(%) in Germany?
Make the answer very short. 2.34. 